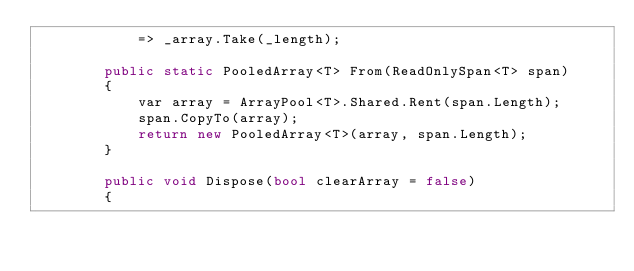Convert code to text. <code><loc_0><loc_0><loc_500><loc_500><_C#_>            => _array.Take(_length);

        public static PooledArray<T> From(ReadOnlySpan<T> span)
        {
            var array = ArrayPool<T>.Shared.Rent(span.Length);
            span.CopyTo(array);
            return new PooledArray<T>(array, span.Length);
        }

        public void Dispose(bool clearArray = false)
        {</code> 